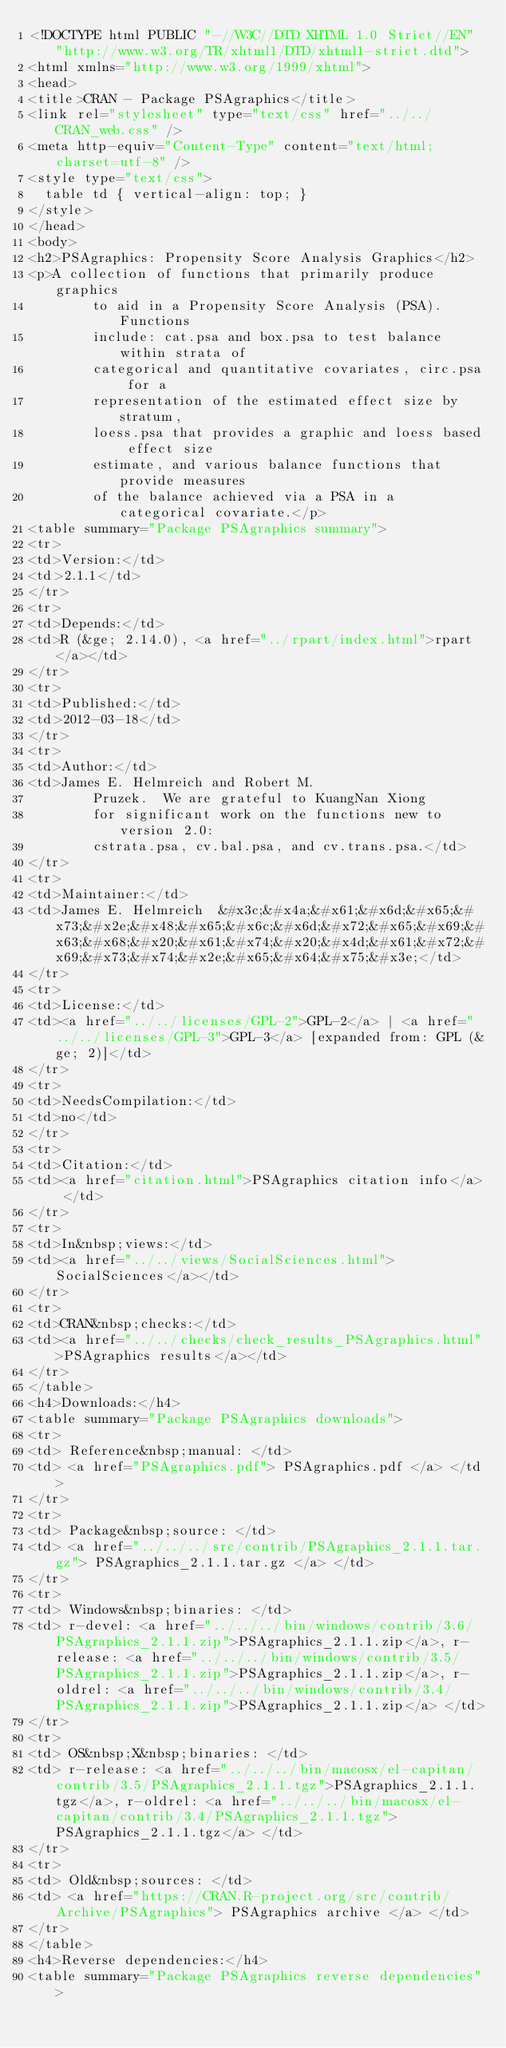<code> <loc_0><loc_0><loc_500><loc_500><_HTML_><!DOCTYPE html PUBLIC "-//W3C//DTD XHTML 1.0 Strict//EN" "http://www.w3.org/TR/xhtml1/DTD/xhtml1-strict.dtd">
<html xmlns="http://www.w3.org/1999/xhtml">
<head>
<title>CRAN - Package PSAgraphics</title>
<link rel="stylesheet" type="text/css" href="../../CRAN_web.css" />
<meta http-equiv="Content-Type" content="text/html; charset=utf-8" />
<style type="text/css">
  table td { vertical-align: top; }
</style>
</head>
<body>
<h2>PSAgraphics: Propensity Score Analysis Graphics</h2>
<p>A collection of functions that primarily produce graphics
        to aid in a Propensity Score Analysis (PSA).  Functions
        include: cat.psa and box.psa to test balance within strata of
        categorical and quantitative covariates, circ.psa for a
        representation of the estimated effect size by stratum,
        loess.psa that provides a graphic and loess based effect size
        estimate, and various balance functions that provide measures
        of the balance achieved via a PSA in a categorical covariate.</p>
<table summary="Package PSAgraphics summary">
<tr>
<td>Version:</td>
<td>2.1.1</td>
</tr>
<tr>
<td>Depends:</td>
<td>R (&ge; 2.14.0), <a href="../rpart/index.html">rpart</a></td>
</tr>
<tr>
<td>Published:</td>
<td>2012-03-18</td>
</tr>
<tr>
<td>Author:</td>
<td>James E. Helmreich and Robert M.
        Pruzek.  We are grateful to KuangNan Xiong
        for significant work on the functions new to version 2.0:
        cstrata.psa, cv.bal.psa, and cv.trans.psa.</td>
</tr>
<tr>
<td>Maintainer:</td>
<td>James E. Helmreich  &#x3c;&#x4a;&#x61;&#x6d;&#x65;&#x73;&#x2e;&#x48;&#x65;&#x6c;&#x6d;&#x72;&#x65;&#x69;&#x63;&#x68;&#x20;&#x61;&#x74;&#x20;&#x4d;&#x61;&#x72;&#x69;&#x73;&#x74;&#x2e;&#x65;&#x64;&#x75;&#x3e;</td>
</tr>
<tr>
<td>License:</td>
<td><a href="../../licenses/GPL-2">GPL-2</a> | <a href="../../licenses/GPL-3">GPL-3</a> [expanded from: GPL (&ge; 2)]</td>
</tr>
<tr>
<td>NeedsCompilation:</td>
<td>no</td>
</tr>
<tr>
<td>Citation:</td>
<td><a href="citation.html">PSAgraphics citation info</a> </td>
</tr>
<tr>
<td>In&nbsp;views:</td>
<td><a href="../../views/SocialSciences.html">SocialSciences</a></td>
</tr>
<tr>
<td>CRAN&nbsp;checks:</td>
<td><a href="../../checks/check_results_PSAgraphics.html">PSAgraphics results</a></td>
</tr>
</table>
<h4>Downloads:</h4>
<table summary="Package PSAgraphics downloads">
<tr>
<td> Reference&nbsp;manual: </td>
<td> <a href="PSAgraphics.pdf"> PSAgraphics.pdf </a> </td>
</tr>
<tr>
<td> Package&nbsp;source: </td>
<td> <a href="../../../src/contrib/PSAgraphics_2.1.1.tar.gz"> PSAgraphics_2.1.1.tar.gz </a> </td>
</tr>
<tr>
<td> Windows&nbsp;binaries: </td>
<td> r-devel: <a href="../../../bin/windows/contrib/3.6/PSAgraphics_2.1.1.zip">PSAgraphics_2.1.1.zip</a>, r-release: <a href="../../../bin/windows/contrib/3.5/PSAgraphics_2.1.1.zip">PSAgraphics_2.1.1.zip</a>, r-oldrel: <a href="../../../bin/windows/contrib/3.4/PSAgraphics_2.1.1.zip">PSAgraphics_2.1.1.zip</a> </td>
</tr>
<tr>
<td> OS&nbsp;X&nbsp;binaries: </td>
<td> r-release: <a href="../../../bin/macosx/el-capitan/contrib/3.5/PSAgraphics_2.1.1.tgz">PSAgraphics_2.1.1.tgz</a>, r-oldrel: <a href="../../../bin/macosx/el-capitan/contrib/3.4/PSAgraphics_2.1.1.tgz">PSAgraphics_2.1.1.tgz</a> </td>
</tr>
<tr>
<td> Old&nbsp;sources: </td>
<td> <a href="https://CRAN.R-project.org/src/contrib/Archive/PSAgraphics"> PSAgraphics archive </a> </td>
</tr>
</table>
<h4>Reverse dependencies:</h4>
<table summary="Package PSAgraphics reverse dependencies"></code> 